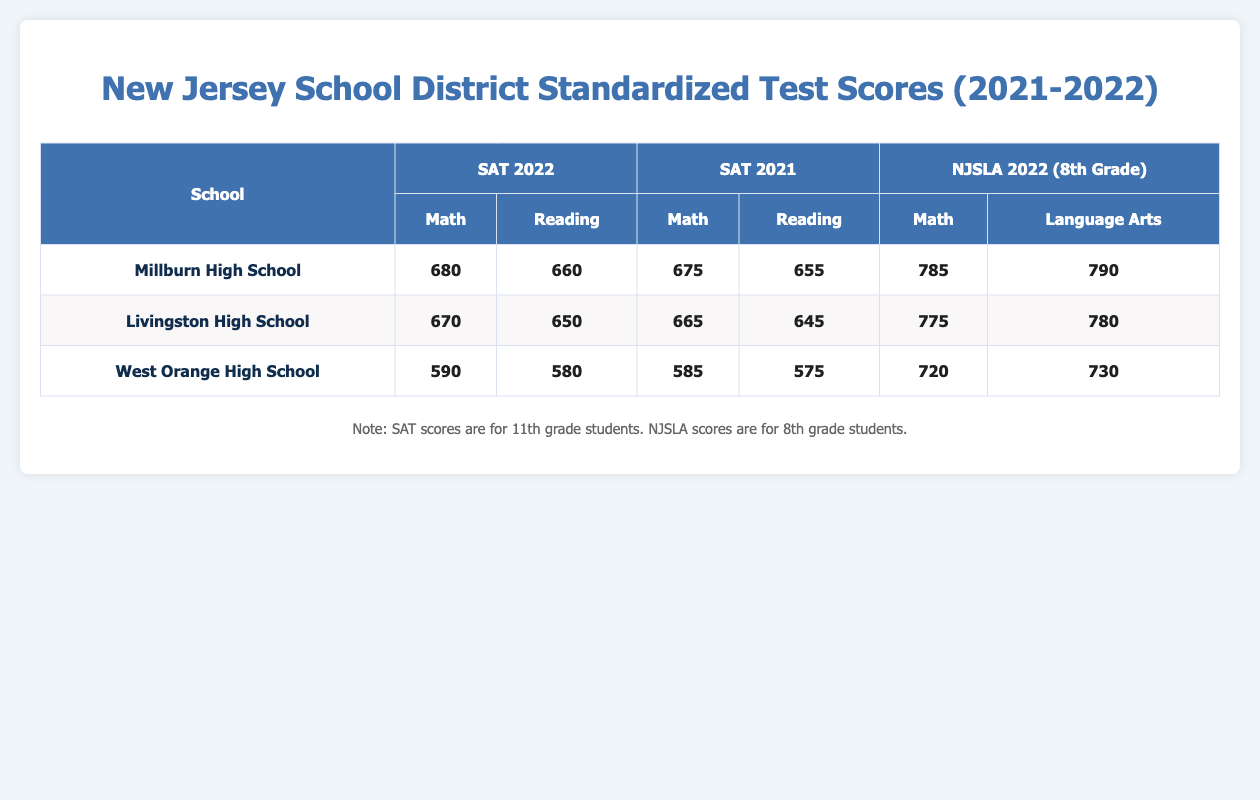What is the average SAT Math score for Millburn High School in 2022? The score for SAT Math at Millburn High School in 2022 is 680. Since there is only one score for that year and type, the average is simply 680.
Answer: 680 Which school had the highest average score in Language Arts for the NJSLA in 2022? Millburn High School had the highest average score in Language Arts with a score of 790, compared to Livingston High School's 780 and West Orange High School's 730.
Answer: Millburn High School What is the difference in average SAT Reading scores between Livingston High School in 2021 and 2022? The average SAT Reading score for Livingston in 2021 is 645 and in 2022 is 650. The difference is 650 - 645 = 5.
Answer: 5 Did West Orange High School improve its average SAT Math score from 2021 to 2022? In 2021, West Orange's SAT Math score was 585 and in 2022, it was 590. Since 590 is greater than 585, West Orange High School did improve.
Answer: Yes What is the total number of students tested for Millburn High School across all subjects in 2022? For Millburn High School in 2022, 320 students were tested for SAT and 290 for NJSLA. Adding these gives 320 + 290 = 610.
Answer: 610 Which school had the lowest average score in Math for the SAT in 2022? West Orange High School had the lowest average SAT Math score in 2022, scoring 590, while Millburn scored 680 and Livingston scored 670.
Answer: West Orange High School What is the average score for 8th-grade Math across all schools in 2022? Calculating the average, we have Millburn at 785, Livingston at 775, and West Orange at 720. Their total is 785 + 775 + 720 = 2280, and divided by 3 gives an average of 2280 / 3 = 760.
Answer: 760 Which subject did Millburn High School perform better in for NJSLA in 2022, Math or Language Arts? Millburn scored 785 in Math and 790 in Language Arts for NJSLA in 2022. Since 790 is higher than 785, they performed better in Language Arts.
Answer: Language Arts What is the overall trend in SAT Math scores for Millburn High School from 2021 to 2022? Looking at the scores, Millburn scored 675 in 2021 and 680 in 2022. Since 680 is higher than 675, the trend shows an increase in SAT Math scores.
Answer: Increase 